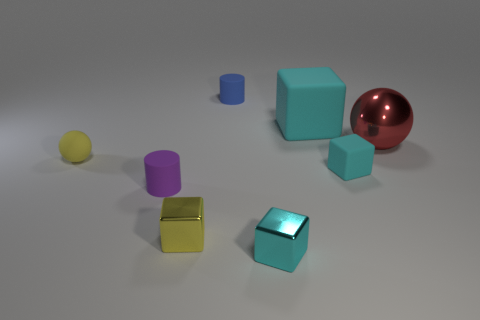How many objects in the image have a cube-like shape? There are three objects in the image that have a cube-like shape, presenting with various sizes and colors, including teal, yellow, and a smaller cube that matches the teal color tone of a larger one. 